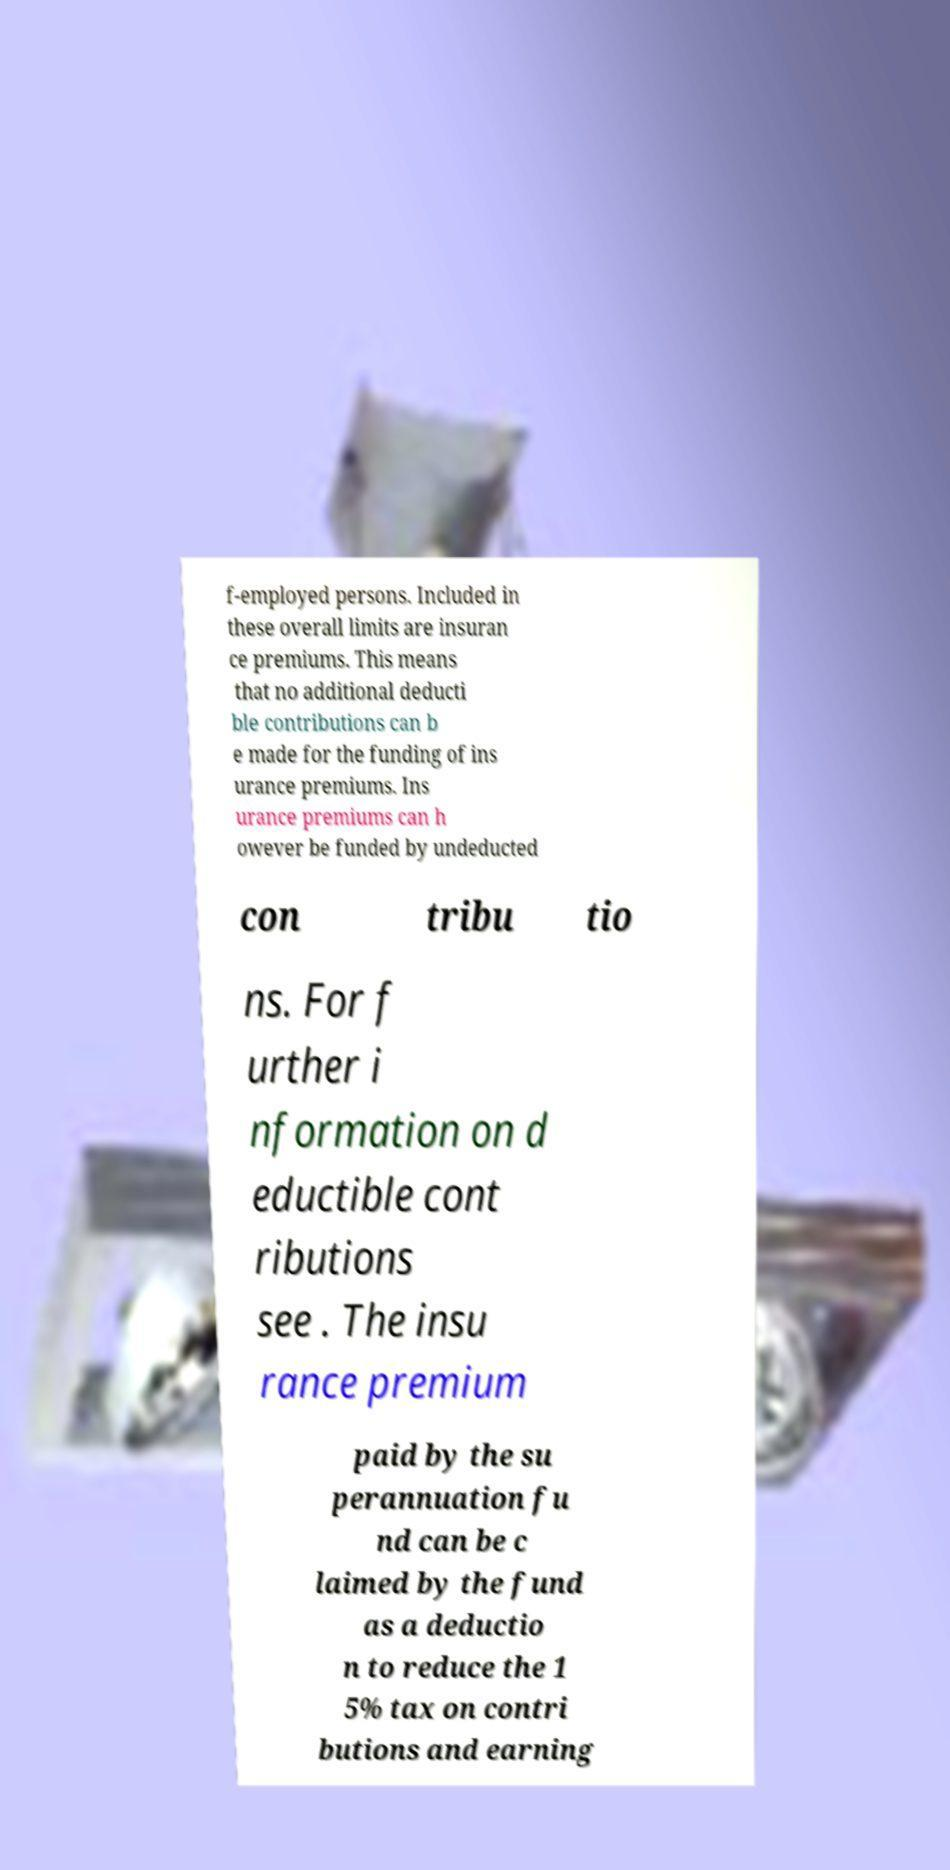There's text embedded in this image that I need extracted. Can you transcribe it verbatim? f-employed persons. Included in these overall limits are insuran ce premiums. This means that no additional deducti ble contributions can b e made for the funding of ins urance premiums. Ins urance premiums can h owever be funded by undeducted con tribu tio ns. For f urther i nformation on d eductible cont ributions see . The insu rance premium paid by the su perannuation fu nd can be c laimed by the fund as a deductio n to reduce the 1 5% tax on contri butions and earning 